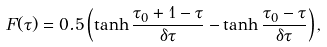Convert formula to latex. <formula><loc_0><loc_0><loc_500><loc_500>F ( \tau ) = 0 . 5 \left ( \tanh \frac { \tau _ { 0 } + 1 - \tau } { \delta \tau } - \tanh \frac { \tau _ { 0 } - \tau } { \delta \tau } \right ) ,</formula> 